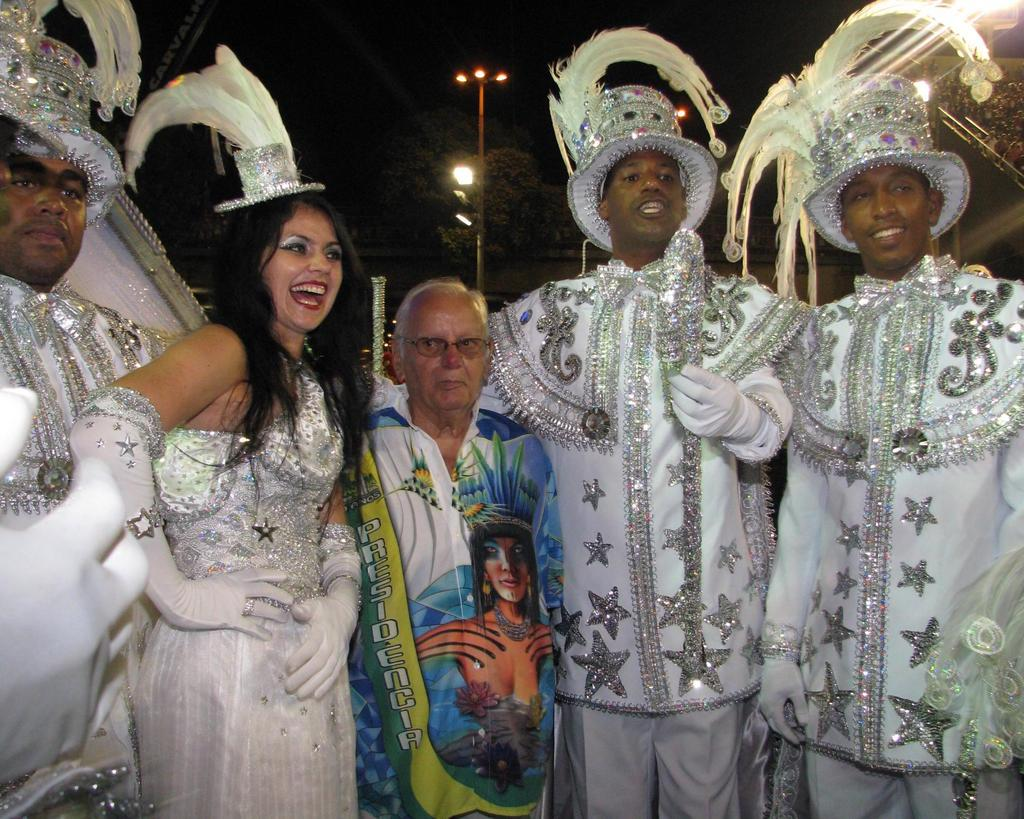What are the people in the image wearing? The people in the image are wearing costumes. What can be seen in the background of the image? There are light poles and trees visible in the background of the image. What type of light is being approved for expansion in the image? There is no mention of light being approved for expansion in the image; the focus is on the people wearing costumes and the background elements. 